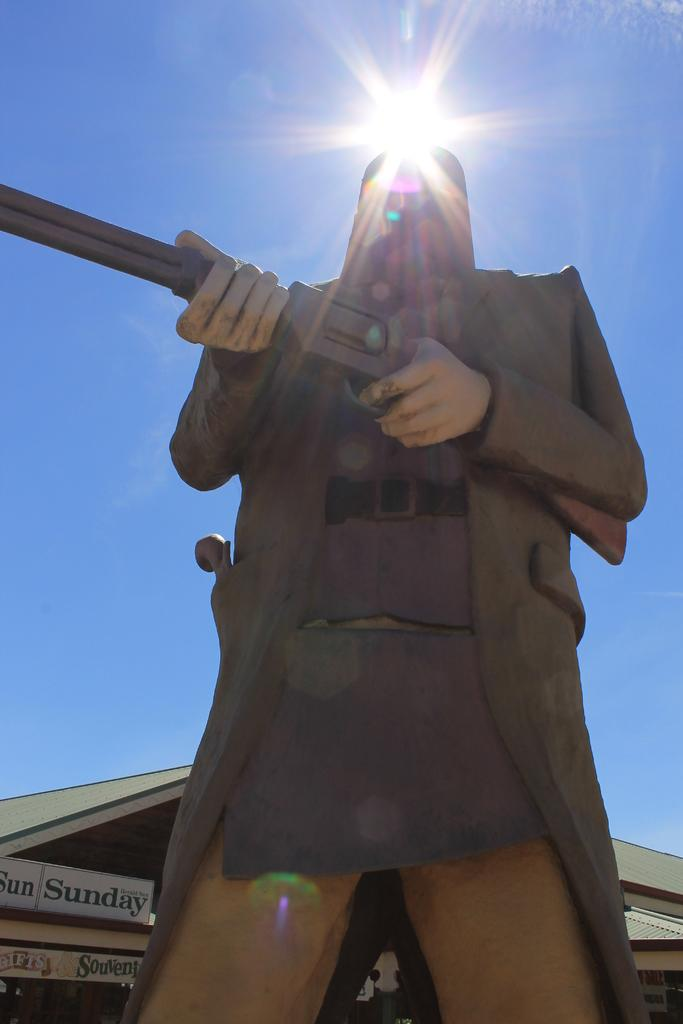What is the statue in the image holding? The statue is holding a gun. What can be seen in the background of the image? There is a building in the background of the image. What is on the building? There are boards on the building. What is visible in the sky in the image? The sky is visible in the background of the image, and the sun is observable. What type of pear is being used as a prop by the snake in the image? There is no pear or snake present in the image; it features a statue holding a gun and a building with boards in the background. 